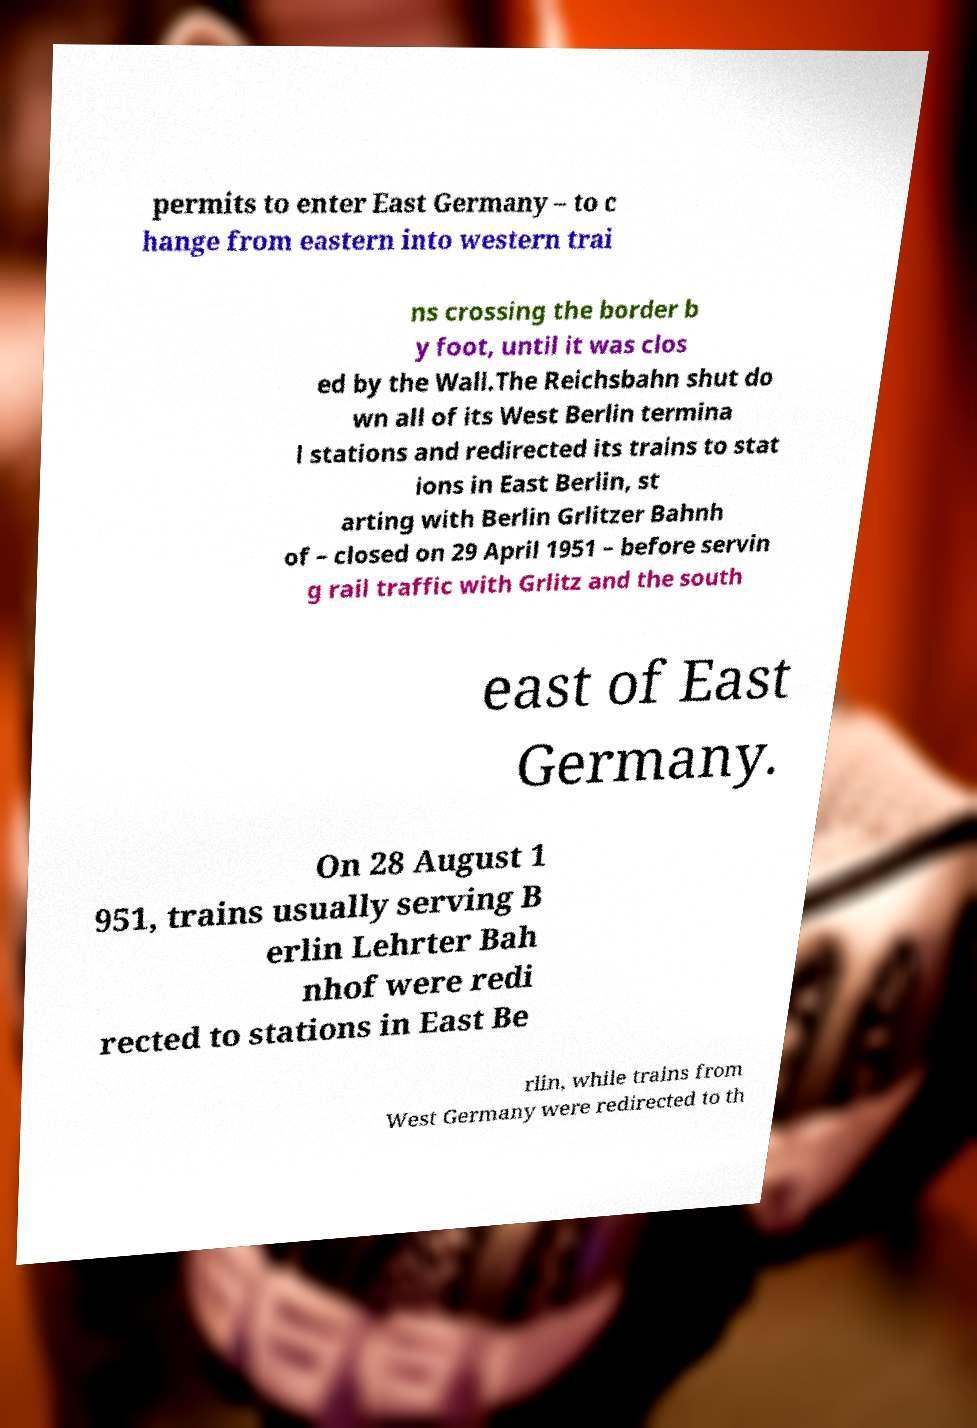Please identify and transcribe the text found in this image. permits to enter East Germany – to c hange from eastern into western trai ns crossing the border b y foot, until it was clos ed by the Wall.The Reichsbahn shut do wn all of its West Berlin termina l stations and redirected its trains to stat ions in East Berlin, st arting with Berlin Grlitzer Bahnh of – closed on 29 April 1951 – before servin g rail traffic with Grlitz and the south east of East Germany. On 28 August 1 951, trains usually serving B erlin Lehrter Bah nhof were redi rected to stations in East Be rlin, while trains from West Germany were redirected to th 